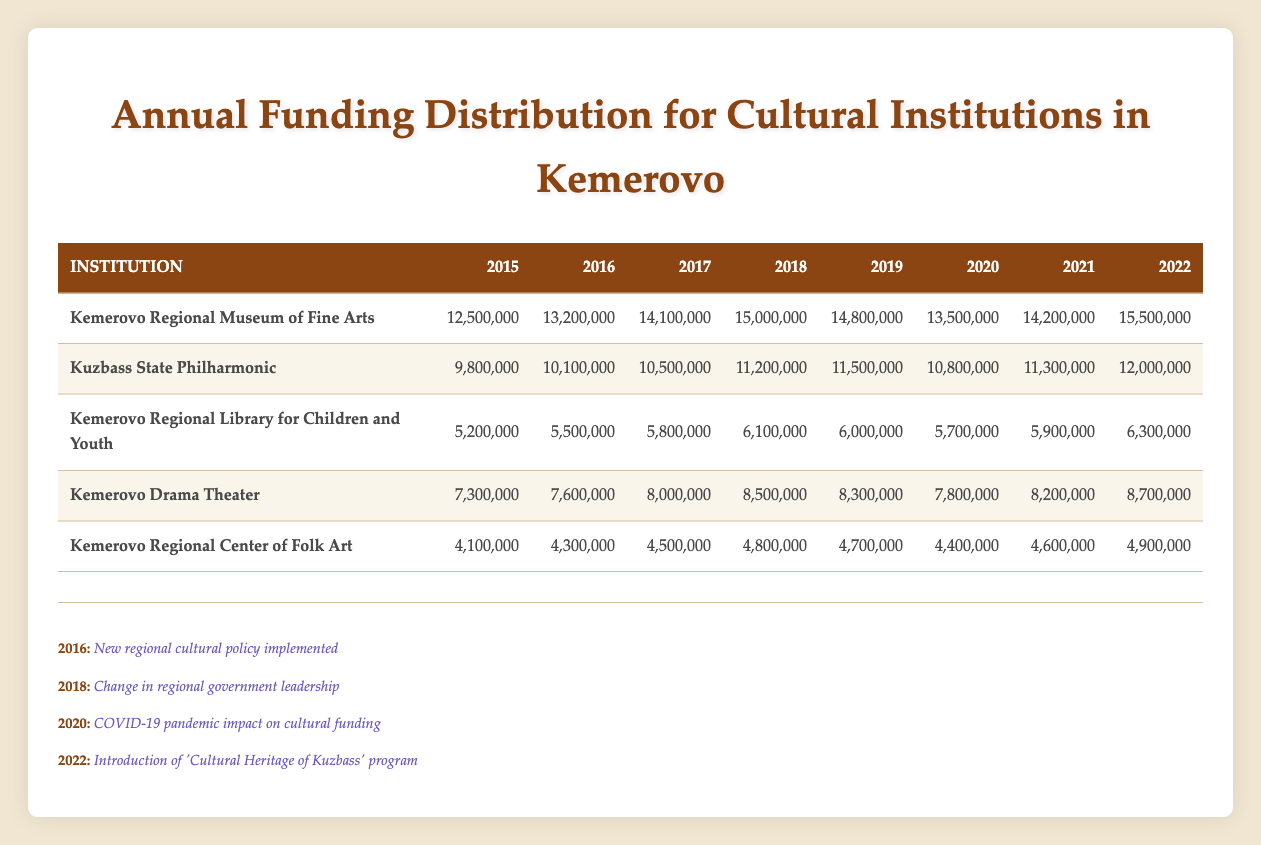What was the funding for the Kemerovo Regional Museum of Fine Arts in 2020? In the table, the funding allocated to the Kemerovo Regional Museum of Fine Arts for the year 2020 is directly listed, which is 13,500,000.
Answer: 13,500,000 What was the total funding for the Kuzbass State Philharmonic from 2015 to 2022? To find the total funding, sum all the annual amounts for the Kuzbass State Philharmonic: 9,800,000 + 10,100,000 + 10,500,000 + 11,200,000 + 11,500,000 + 10,800,000 + 11,300,000 + 12,000,000 = 95,200,000.
Answer: 95,200,000 Did the Kemerovo Regional Library for Children and Youth receive more funding in 2019 compared to 2018? The funding for 2018 was 6,100,000, and for 2019 it was 6,000,000. Since 6,000,000 is less than 6,100,000, the statement is false.
Answer: No What is the average annual funding for the Kemerovo Drama Theater over the years 2015 to 2022? First, sum the total funding for the Kemerovo Drama Theater: 7,300,000 + 7,600,000 + 8,000,000 + 8,500,000 + 8,300,000 + 7,800,000 + 8,200,000 + 8,700,000 = 57,400,000. Then divide by the number of years (8): 57,400,000 / 8 = 7,175,000.
Answer: 7,175,000 In which year did the Kemerovo Regional Center of Folk Art see a decrease in funding compared to the previous year? Looking through the funding for the Kemerovo Regional Center of Folk Art, we find that in 2016 it received 4,300,000, down from 4,100,000 in 2015. This trend continues: 4,800,000 in 2018 was less than 4,700,000 in 2019, confirming there were two such instances.
Answer: 2016 and 2019 What funding event occurred in 2020, and how might it have affected the funding for cultural institutions? The political event in 2020 was the impact of the COVID-19 pandemic on cultural funding, likely leading to reduced funding across various institutions.
Answer: COVID-19 pandemic impact on cultural funding Which institution had the highest funding in 2022 and what was that amount? By comparing the row for each institution, the Kemerovo Regional Museum of Fine Arts had the highest funding in 2022 at 15,500,000, making it the top receiver that year.
Answer: 15,500,000 What was the change in funding for the Kemerovo Regional Museum of Fine Arts from 2016 to 2022? The funding for the Kemerovo Regional Museum of Fine Arts in 2016 was 13,200,000, while in 2022 it was 15,500,000. The change is calculated as 15,500,000 - 13,200,000 = 2,300,000, reflecting an increase.
Answer: 2,300,000 